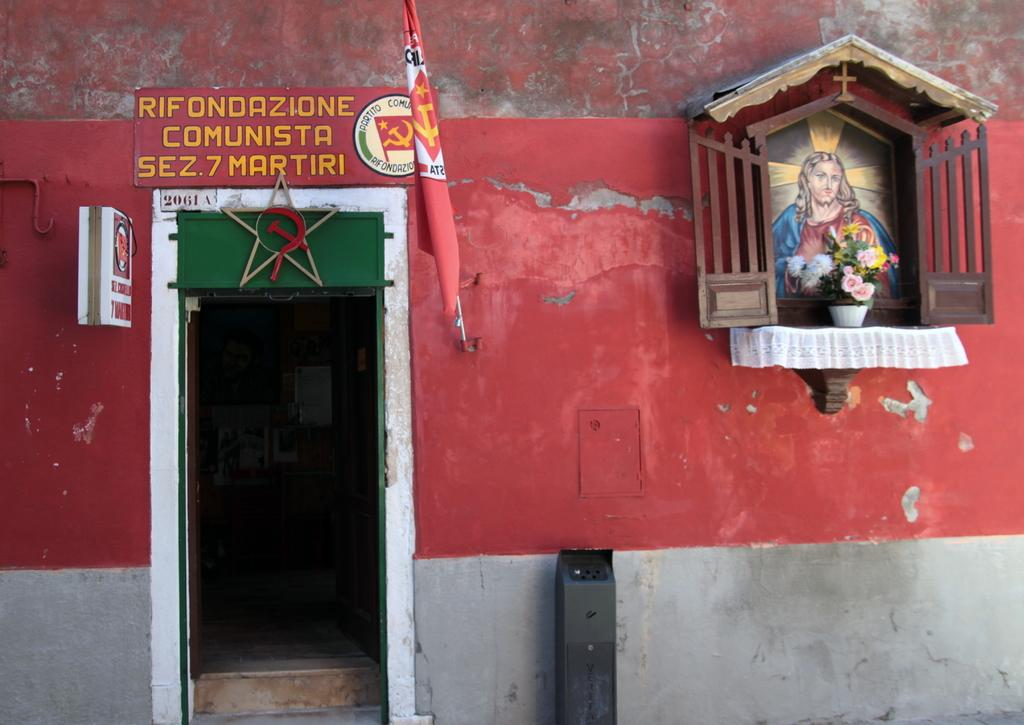What type of structure is visible in the image? There is a building in the image. What color is the building? The building is red. What other red object can be seen in the image? There is a red color flag in the image. What is written on the wall of the building? Something is written on the wall. What religious figure is depicted in the image? There is a photo of Jesus in the image. Where is the flower pot located in the image? The flower pot is on a wooden shelf. What type of jam is being served in the image? There is no jam present in the image. How many bears can be seen interacting with the flower pot in the image? There are no bears present in the image. 